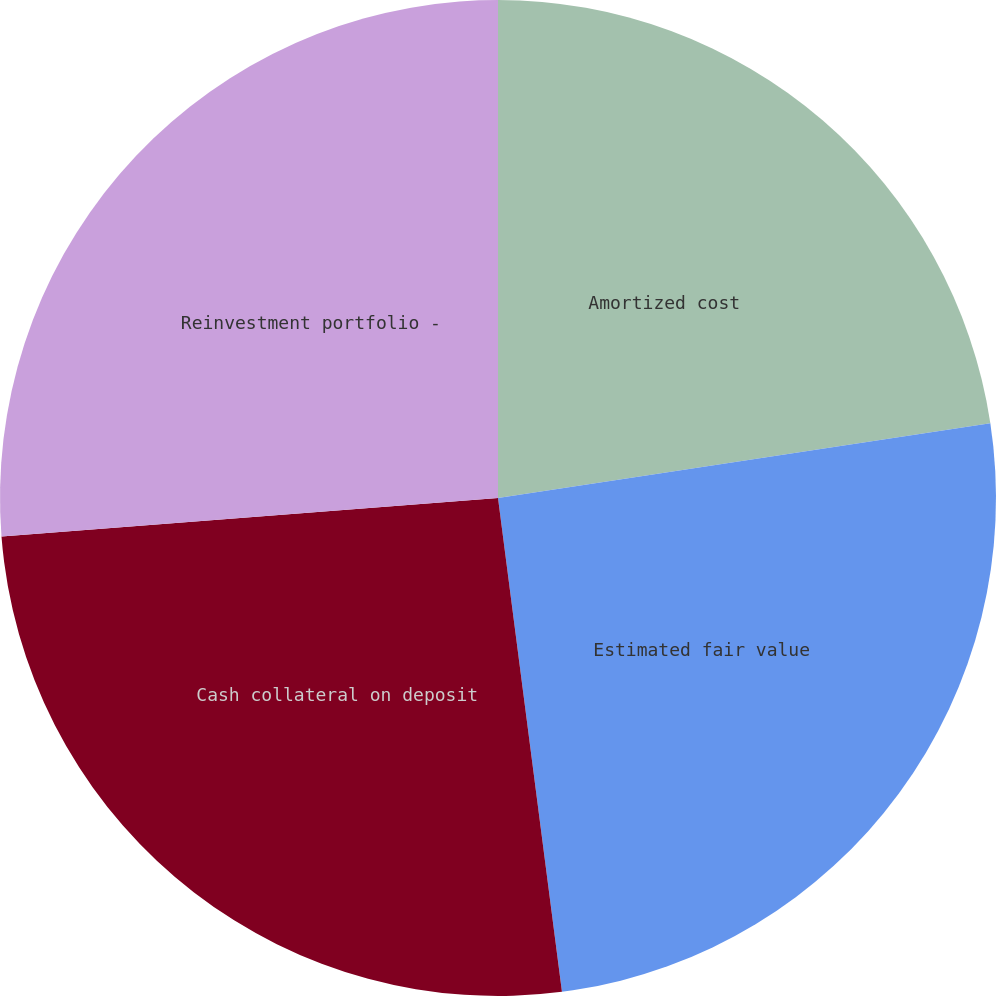<chart> <loc_0><loc_0><loc_500><loc_500><pie_chart><fcel>Amortized cost<fcel>Estimated fair value<fcel>Cash collateral on deposit<fcel>Reinvestment portfolio -<nl><fcel>22.6%<fcel>25.35%<fcel>25.82%<fcel>26.23%<nl></chart> 